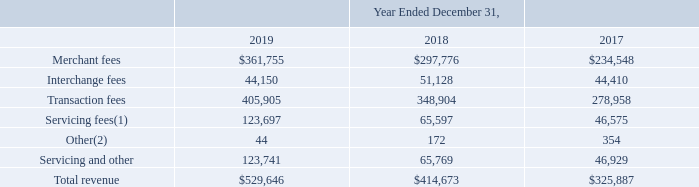GreenSky, Inc. NOTES TO CONSOLIDATED FINANCIAL STATEMENTS — (Continued) (United States Dollars in thousands, except per share data, unless otherwise stated)
Disaggregated revenue
Revenue disaggregated by type of service was as follows for the periods presented:
(1) For the year ended December 31, 2019, includes a $30,459 change in fair value of our servicing asset primarily associated with increases to the contractually specified fixed servicing fees for certain Bank Partners. Refer to Note 3 for additional information.
(2) Other revenue includes miscellaneous revenue items that are individually immaterial. Other revenue is presented separately herein in order to clearly present merchant, interchange and servicing fees, which are more integral to our primary operations and better enable financial statement users to calculate metrics such as servicing and merchant fee yields.
No assets were recognized from the costs to obtain or fulfill a contract with a customer as of December 31,
2019 and 2018. We recognized bad debt expense arising from our contracts with customers of $950, $1,294 and
$817 during the years ended December 31, 2019, 2018 and 2017, respectively, which is recorded within general and
administrative expense in our Consolidated Statements of Operations.
How much was the included change in fair value of the company's servicing asset included in its servicing fees?
Answer scale should be: thousand. 30,459. What does other revenue include? Miscellaneous revenue items that are individually immaterial. other revenue is presented separately herein in order to clearly present merchant, interchange and servicing fees. Which years does the table provide information for Revenue disaggregated by type of service? 2019, 2018, 2017. How many years did Interchange fees exceed $50,000 thousand? 2018
Answer: 1. What was the change in the transaction fees between 2017 and 2019?
Answer scale should be: thousand. 405,905-278,958
Answer: 126947. What was the percentage change in the total revenue between 2018 and 2019?
Answer scale should be: percent. (529,646-414,673)/414,673
Answer: 27.73. 